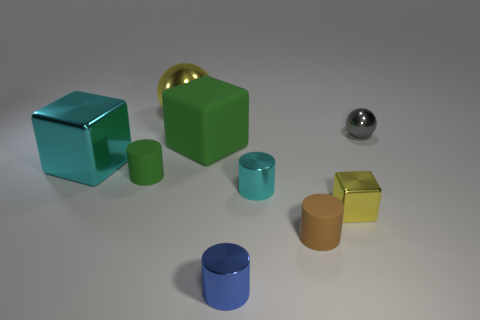Are the objects in the scene arranged in any specific order or pattern? The objects are not arranged in a specific sequence that suggests a deliberate pattern, but they are placed in an orderly manner, with varying distances between them. Their placement does not seem to follow a numerical or color-based sequence but may be positioned to create a visually balanced composition. 